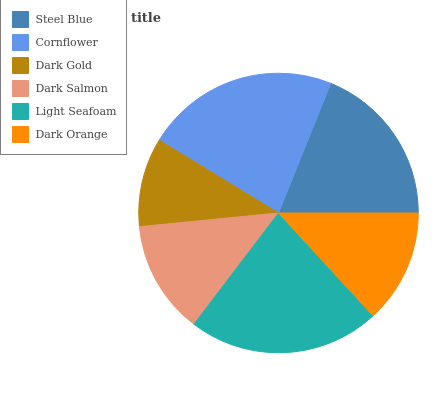Is Dark Gold the minimum?
Answer yes or no. Yes. Is Cornflower the maximum?
Answer yes or no. Yes. Is Cornflower the minimum?
Answer yes or no. No. Is Dark Gold the maximum?
Answer yes or no. No. Is Cornflower greater than Dark Gold?
Answer yes or no. Yes. Is Dark Gold less than Cornflower?
Answer yes or no. Yes. Is Dark Gold greater than Cornflower?
Answer yes or no. No. Is Cornflower less than Dark Gold?
Answer yes or no. No. Is Steel Blue the high median?
Answer yes or no. Yes. Is Dark Orange the low median?
Answer yes or no. Yes. Is Cornflower the high median?
Answer yes or no. No. Is Dark Gold the low median?
Answer yes or no. No. 